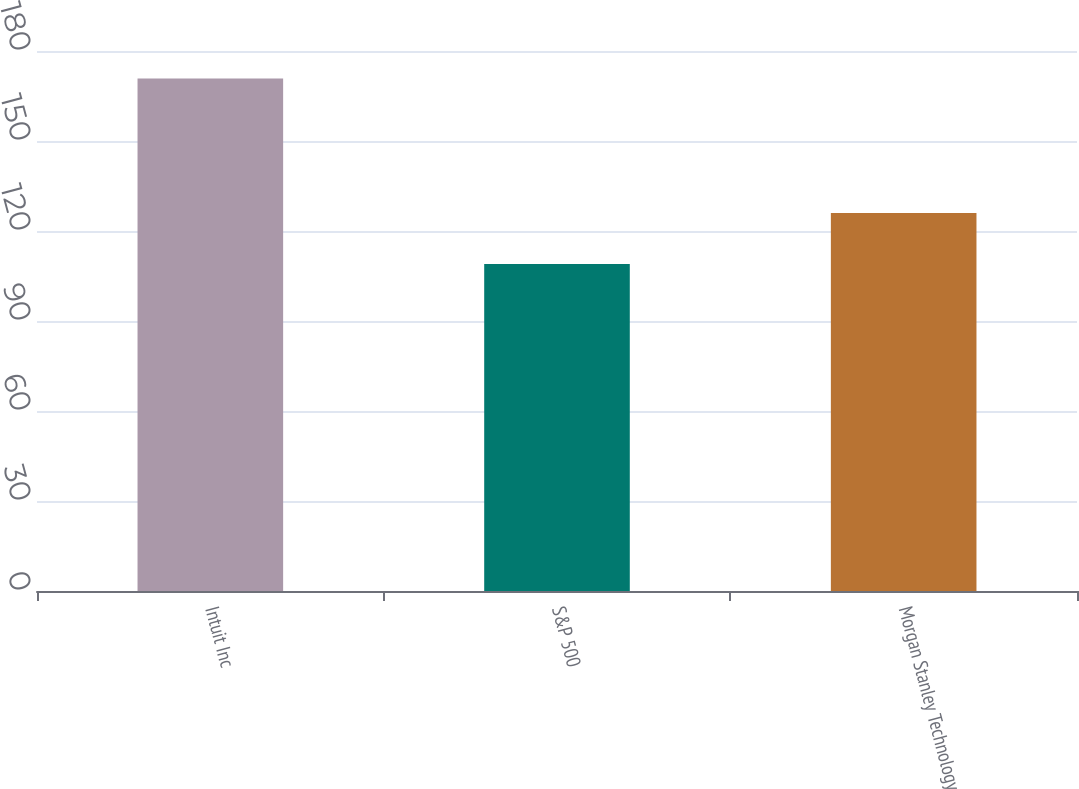Convert chart. <chart><loc_0><loc_0><loc_500><loc_500><bar_chart><fcel>Intuit Inc<fcel>S&P 500<fcel>Morgan Stanley Technology<nl><fcel>170.87<fcel>109.02<fcel>125.99<nl></chart> 